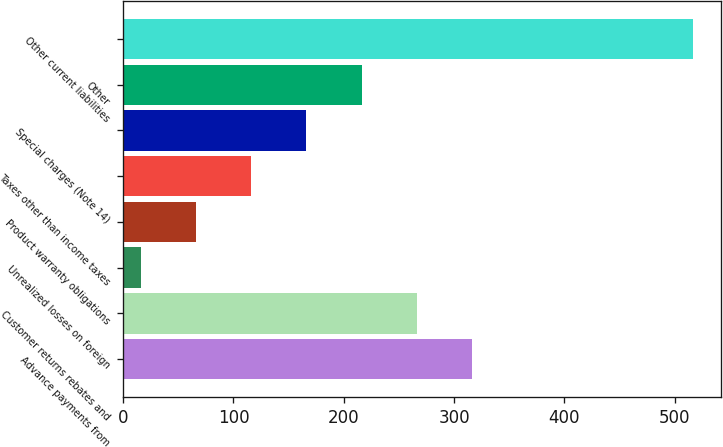Convert chart. <chart><loc_0><loc_0><loc_500><loc_500><bar_chart><fcel>Advance payments from<fcel>Customer returns rebates and<fcel>Unrealized losses on foreign<fcel>Product warranty obligations<fcel>Taxes other than income taxes<fcel>Special charges (Note 14)<fcel>Other<fcel>Other current liabilities<nl><fcel>316.26<fcel>266.25<fcel>16.2<fcel>66.21<fcel>116.22<fcel>166.23<fcel>216.24<fcel>516.3<nl></chart> 